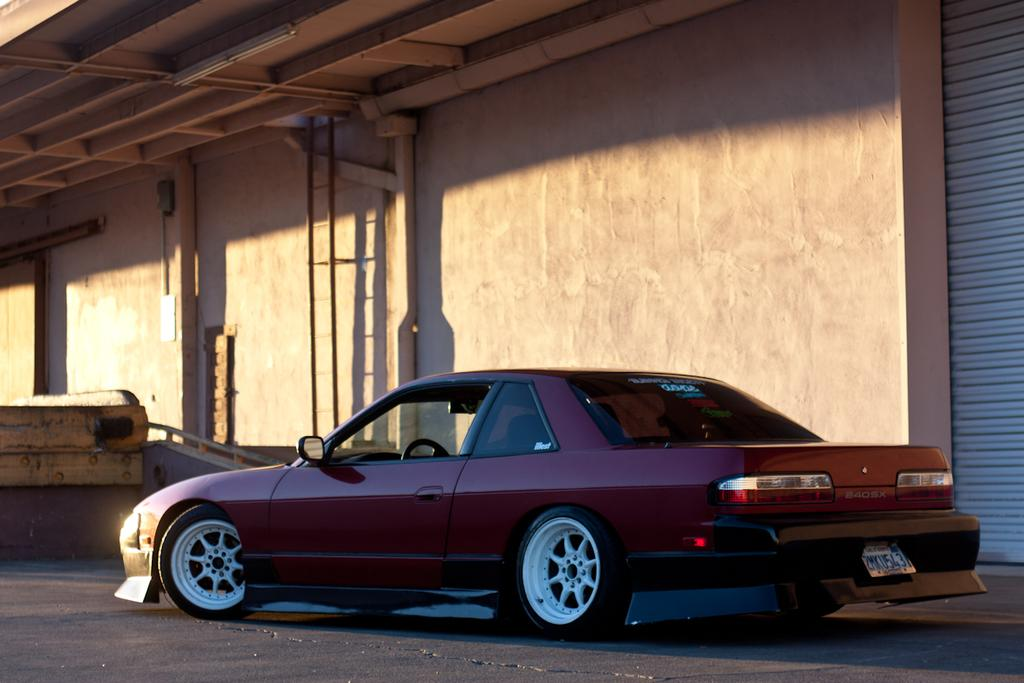What is the main subject of the image? There is a car on the road in the image. What can be seen in the background of the image? In the background, there is a shutter, pillars, and a wall. Where is the light located in the image? The light is at the top of the image. How many books does the dad have in the image? There are no books or dad present in the image. Can you describe the dad's breathing pattern in the image? There is no dad or any indication of breathing in the image. 